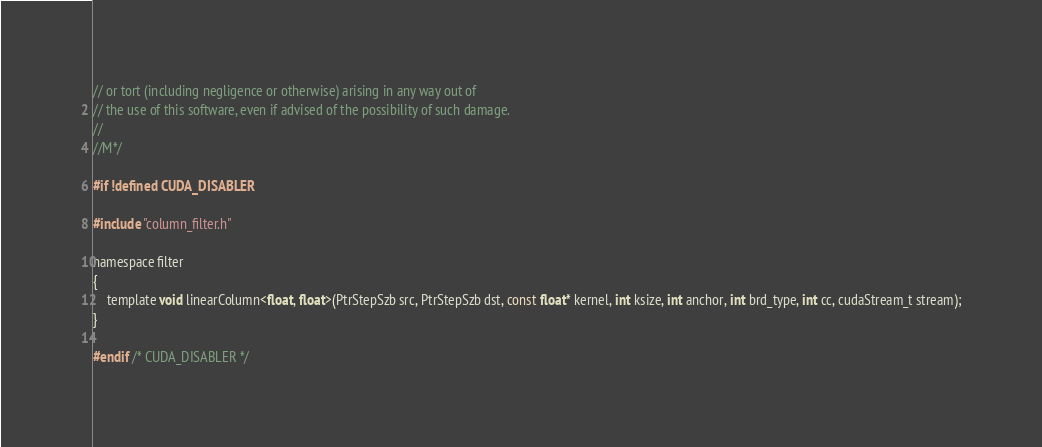<code> <loc_0><loc_0><loc_500><loc_500><_Cuda_>// or tort (including negligence or otherwise) arising in any way out of
// the use of this software, even if advised of the possibility of such damage.
//
//M*/

#if !defined CUDA_DISABLER

#include "column_filter.h"

namespace filter
{
    template void linearColumn<float, float>(PtrStepSzb src, PtrStepSzb dst, const float* kernel, int ksize, int anchor, int brd_type, int cc, cudaStream_t stream);
}

#endif /* CUDA_DISABLER */
</code> 